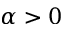<formula> <loc_0><loc_0><loc_500><loc_500>\alpha > 0</formula> 